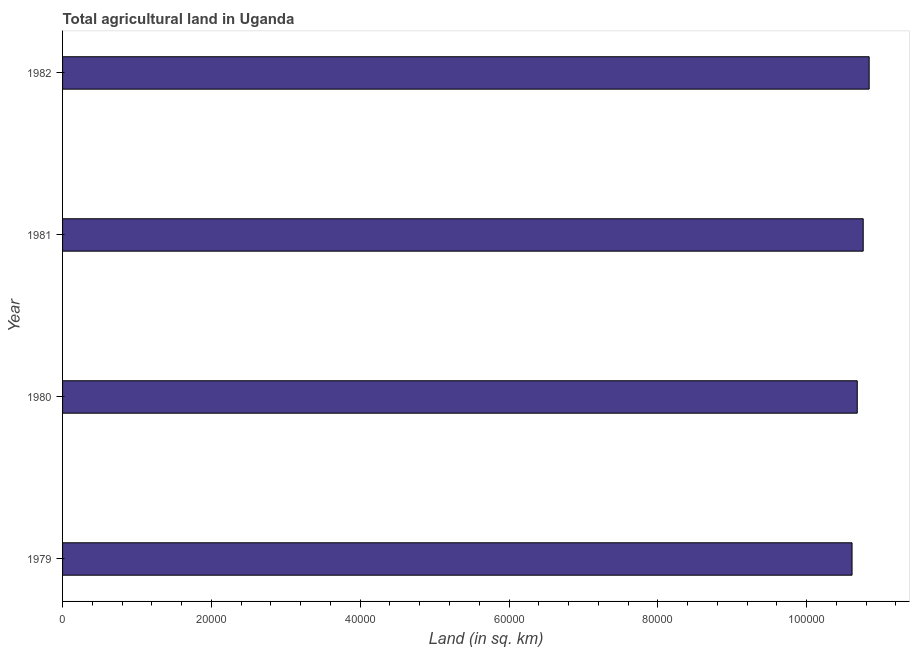Does the graph contain any zero values?
Your answer should be very brief. No. What is the title of the graph?
Ensure brevity in your answer.  Total agricultural land in Uganda. What is the label or title of the X-axis?
Provide a succinct answer. Land (in sq. km). What is the label or title of the Y-axis?
Your answer should be very brief. Year. What is the agricultural land in 1982?
Offer a very short reply. 1.08e+05. Across all years, what is the maximum agricultural land?
Your answer should be compact. 1.08e+05. Across all years, what is the minimum agricultural land?
Provide a succinct answer. 1.06e+05. In which year was the agricultural land minimum?
Provide a short and direct response. 1979. What is the sum of the agricultural land?
Give a very brief answer. 4.29e+05. What is the difference between the agricultural land in 1979 and 1981?
Offer a terse response. -1500. What is the average agricultural land per year?
Offer a terse response. 1.07e+05. What is the median agricultural land?
Provide a short and direct response. 1.07e+05. Do a majority of the years between 1982 and 1980 (inclusive) have agricultural land greater than 12000 sq. km?
Make the answer very short. Yes. What is the difference between the highest and the second highest agricultural land?
Your answer should be very brief. 800. What is the difference between the highest and the lowest agricultural land?
Keep it short and to the point. 2300. How many bars are there?
Give a very brief answer. 4. Are all the bars in the graph horizontal?
Keep it short and to the point. Yes. Are the values on the major ticks of X-axis written in scientific E-notation?
Offer a terse response. No. What is the Land (in sq. km) of 1979?
Provide a short and direct response. 1.06e+05. What is the Land (in sq. km) of 1980?
Your answer should be very brief. 1.07e+05. What is the Land (in sq. km) of 1981?
Keep it short and to the point. 1.08e+05. What is the Land (in sq. km) of 1982?
Give a very brief answer. 1.08e+05. What is the difference between the Land (in sq. km) in 1979 and 1980?
Give a very brief answer. -700. What is the difference between the Land (in sq. km) in 1979 and 1981?
Offer a terse response. -1500. What is the difference between the Land (in sq. km) in 1979 and 1982?
Ensure brevity in your answer.  -2300. What is the difference between the Land (in sq. km) in 1980 and 1981?
Make the answer very short. -800. What is the difference between the Land (in sq. km) in 1980 and 1982?
Provide a succinct answer. -1600. What is the difference between the Land (in sq. km) in 1981 and 1982?
Provide a short and direct response. -800. What is the ratio of the Land (in sq. km) in 1979 to that in 1982?
Offer a very short reply. 0.98. What is the ratio of the Land (in sq. km) in 1980 to that in 1982?
Offer a very short reply. 0.98. What is the ratio of the Land (in sq. km) in 1981 to that in 1982?
Your response must be concise. 0.99. 